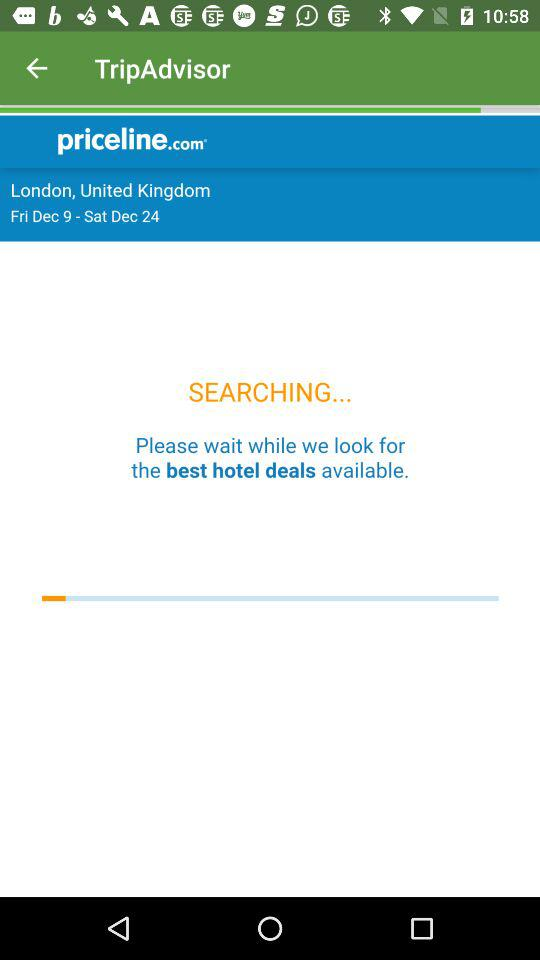How many days are in the search range?
Answer the question using a single word or phrase. 16 